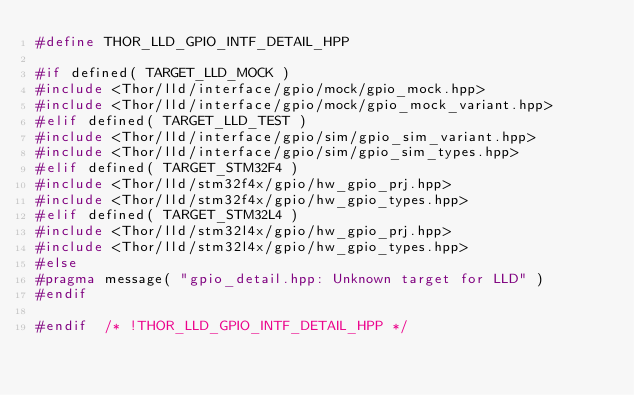<code> <loc_0><loc_0><loc_500><loc_500><_C++_>#define THOR_LLD_GPIO_INTF_DETAIL_HPP

#if defined( TARGET_LLD_MOCK )
#include <Thor/lld/interface/gpio/mock/gpio_mock.hpp>
#include <Thor/lld/interface/gpio/mock/gpio_mock_variant.hpp>
#elif defined( TARGET_LLD_TEST )
#include <Thor/lld/interface/gpio/sim/gpio_sim_variant.hpp>
#include <Thor/lld/interface/gpio/sim/gpio_sim_types.hpp>
#elif defined( TARGET_STM32F4 )
#include <Thor/lld/stm32f4x/gpio/hw_gpio_prj.hpp>
#include <Thor/lld/stm32f4x/gpio/hw_gpio_types.hpp>
#elif defined( TARGET_STM32L4 )
#include <Thor/lld/stm32l4x/gpio/hw_gpio_prj.hpp>
#include <Thor/lld/stm32l4x/gpio/hw_gpio_types.hpp>
#else
#pragma message( "gpio_detail.hpp: Unknown target for LLD" )
#endif

#endif  /* !THOR_LLD_GPIO_INTF_DETAIL_HPP */
</code> 